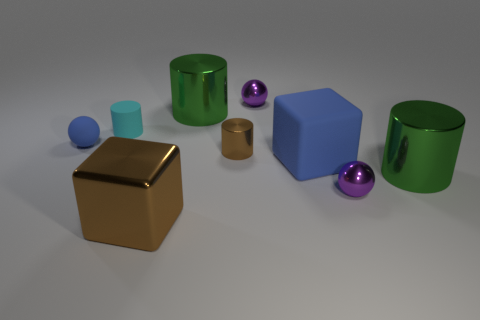What is the material of the small blue sphere left of the large blue thing?
Your answer should be compact. Rubber. Are there the same number of small cyan rubber cylinders behind the small cyan thing and cylinders?
Your answer should be very brief. No. Does the big brown metallic thing have the same shape as the cyan object?
Your answer should be very brief. No. Is there any other thing that is the same color as the big matte thing?
Your answer should be compact. Yes. What is the shape of the metallic object that is in front of the large blue block and to the left of the large blue thing?
Ensure brevity in your answer.  Cube. Is the number of tiny purple shiny things behind the tiny cyan matte object the same as the number of green cylinders that are in front of the tiny brown cylinder?
Offer a very short reply. Yes. How many balls are brown metal things or large blue matte objects?
Your answer should be compact. 0. How many brown cylinders have the same material as the brown block?
Your response must be concise. 1. There is a small thing that is the same color as the large matte cube; what shape is it?
Offer a very short reply. Sphere. What is the thing that is right of the tiny shiny cylinder and behind the tiny cyan matte cylinder made of?
Give a very brief answer. Metal. 